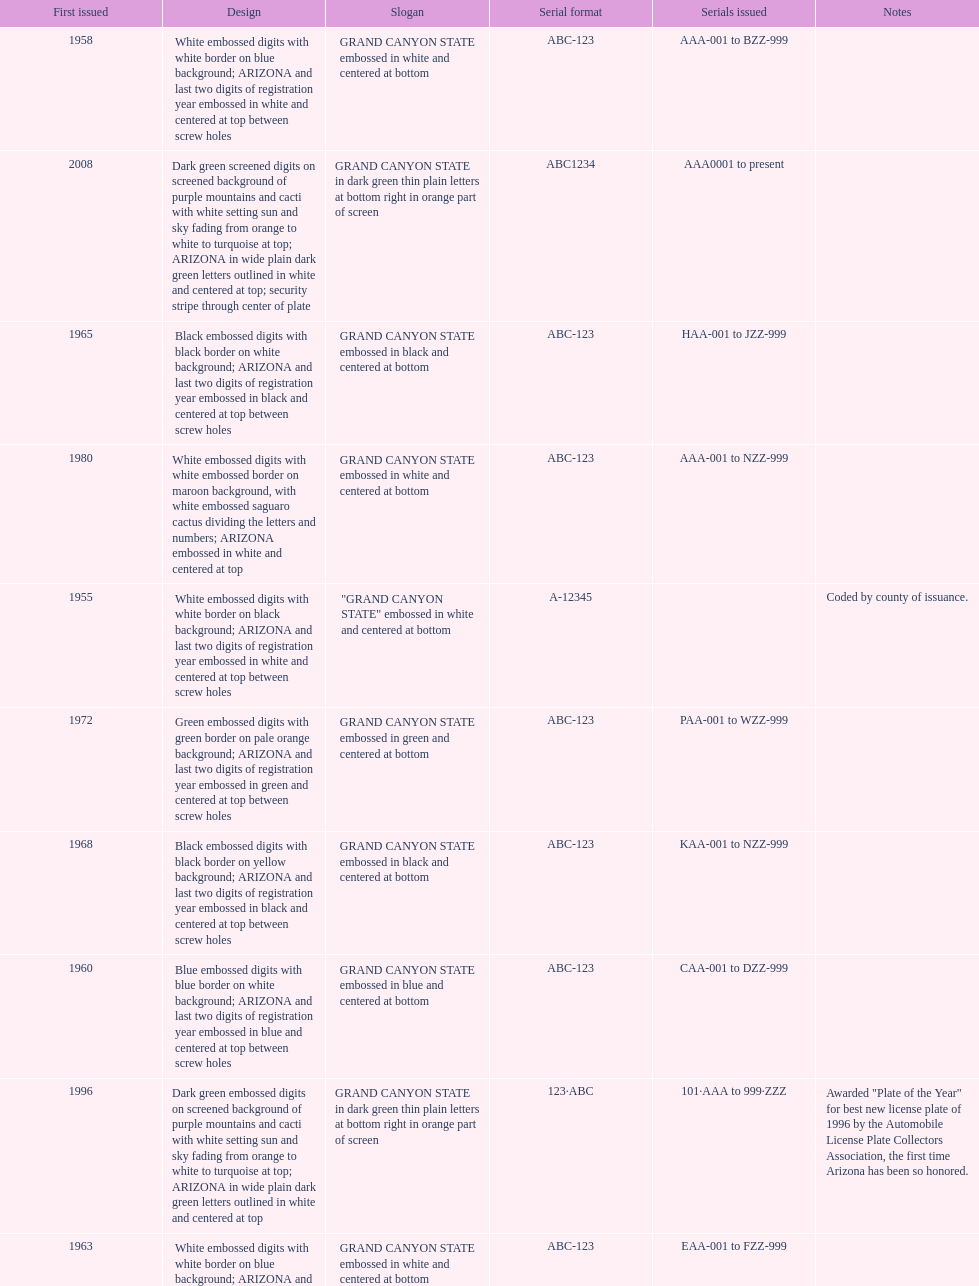Which year featured the license plate with the least characters? 1955. 